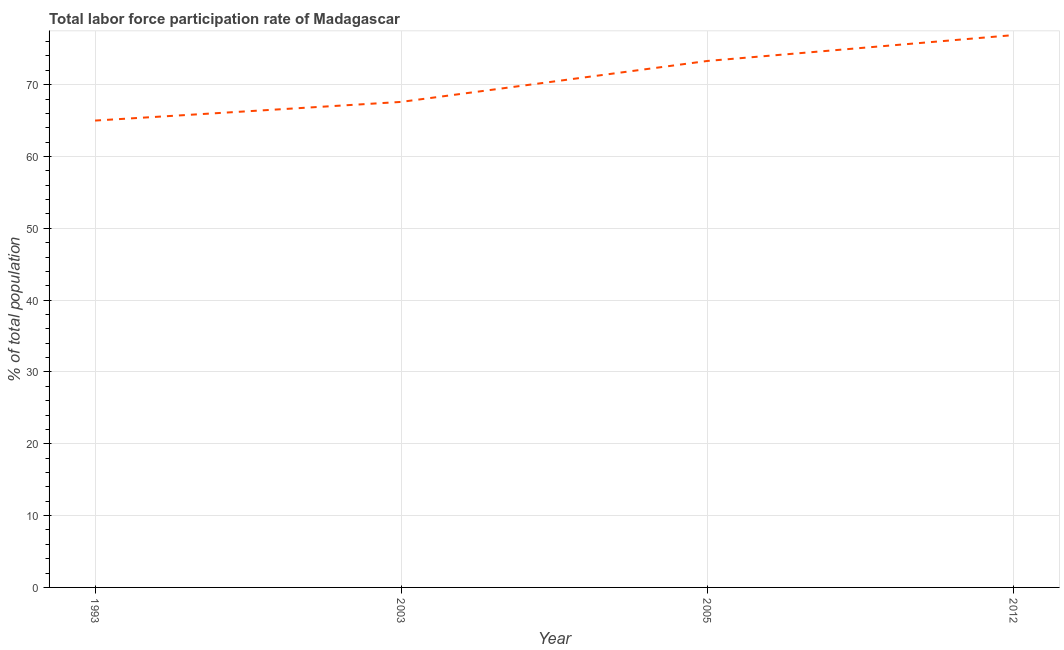What is the total labor force participation rate in 2005?
Your response must be concise. 73.3. Across all years, what is the maximum total labor force participation rate?
Provide a short and direct response. 76.9. In which year was the total labor force participation rate minimum?
Keep it short and to the point. 1993. What is the sum of the total labor force participation rate?
Offer a terse response. 282.8. What is the difference between the total labor force participation rate in 2003 and 2005?
Offer a terse response. -5.7. What is the average total labor force participation rate per year?
Provide a short and direct response. 70.7. What is the median total labor force participation rate?
Your answer should be very brief. 70.45. Do a majority of the years between 2012 and 2005 (inclusive) have total labor force participation rate greater than 30 %?
Ensure brevity in your answer.  No. What is the ratio of the total labor force participation rate in 2003 to that in 2012?
Ensure brevity in your answer.  0.88. What is the difference between the highest and the second highest total labor force participation rate?
Your answer should be very brief. 3.6. What is the difference between the highest and the lowest total labor force participation rate?
Offer a very short reply. 11.9. Are the values on the major ticks of Y-axis written in scientific E-notation?
Offer a terse response. No. Does the graph contain grids?
Your answer should be compact. Yes. What is the title of the graph?
Make the answer very short. Total labor force participation rate of Madagascar. What is the label or title of the X-axis?
Ensure brevity in your answer.  Year. What is the label or title of the Y-axis?
Your response must be concise. % of total population. What is the % of total population in 1993?
Keep it short and to the point. 65. What is the % of total population in 2003?
Your answer should be very brief. 67.6. What is the % of total population of 2005?
Provide a short and direct response. 73.3. What is the % of total population of 2012?
Keep it short and to the point. 76.9. What is the difference between the % of total population in 1993 and 2012?
Your response must be concise. -11.9. What is the difference between the % of total population in 2005 and 2012?
Your response must be concise. -3.6. What is the ratio of the % of total population in 1993 to that in 2003?
Make the answer very short. 0.96. What is the ratio of the % of total population in 1993 to that in 2005?
Your answer should be very brief. 0.89. What is the ratio of the % of total population in 1993 to that in 2012?
Keep it short and to the point. 0.84. What is the ratio of the % of total population in 2003 to that in 2005?
Your response must be concise. 0.92. What is the ratio of the % of total population in 2003 to that in 2012?
Your answer should be compact. 0.88. What is the ratio of the % of total population in 2005 to that in 2012?
Keep it short and to the point. 0.95. 